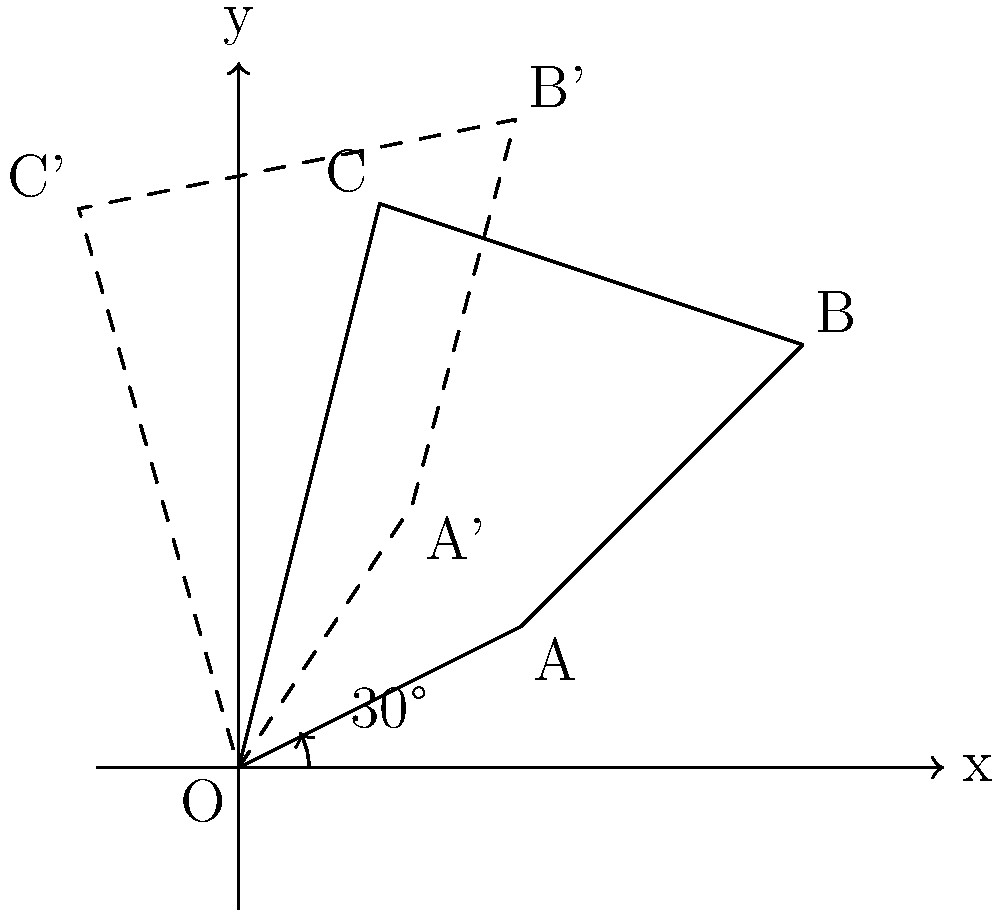A 2D circuit diagram is represented by the quadrilateral OABC in the coordinate system. To enhance component security, the diagram needs to be rotated 30° counterclockwise around the origin. After rotation, what are the new coordinates of point B (represented as B' in the diagram)? To find the new coordinates of point B after rotation, we can follow these steps:

1. Identify the original coordinates of point B: (4, 3)

2. Use the 2D rotation matrix for a counterclockwise rotation of θ degrees:
   $$\begin{bmatrix} \cos\theta & -\sin\theta \\ \sin\theta & \cos\theta \end{bmatrix}$$

3. For a 30° rotation, θ = 30°. Calculate the sine and cosine values:
   $\cos 30° = \frac{\sqrt{3}}{2}$
   $\sin 30° = \frac{1}{2}$

4. Apply the rotation matrix to the coordinates of B(4, 3):
   $$\begin{bmatrix} \cos 30° & -\sin 30° \\ \sin 30° & \cos 30° \end{bmatrix} \begin{bmatrix} 4 \\ 3 \end{bmatrix}$$

5. Multiply the matrices:
   $$\begin{bmatrix} \frac{\sqrt{3}}{2} & -\frac{1}{2} \\ \frac{1}{2} & \frac{\sqrt{3}}{2} \end{bmatrix} \begin{bmatrix} 4 \\ 3 \end{bmatrix} = \begin{bmatrix} 4\frac{\sqrt{3}}{2} - \frac{3}{2} \\ 2 + 3\frac{\sqrt{3}}{2} \end{bmatrix}$$

6. Simplify the result:
   x' = $4\frac{\sqrt{3}}{2} - \frac{3}{2} = 2\sqrt{3} - \frac{3}{2}$
   y' = $2 + 3\frac{\sqrt{3}}{2} = 2 + \frac{3\sqrt{3}}{2}$

Therefore, the new coordinates of point B after rotation are $(2\sqrt{3} - \frac{3}{2}, 2 + \frac{3\sqrt{3}}{2})$.
Answer: $(2\sqrt{3} - \frac{3}{2}, 2 + \frac{3\sqrt{3}}{2})$ 